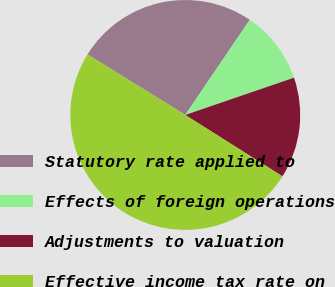Convert chart. <chart><loc_0><loc_0><loc_500><loc_500><pie_chart><fcel>Statutory rate applied to<fcel>Effects of foreign operations<fcel>Adjustments to valuation<fcel>Effective income tax rate on<nl><fcel>25.66%<fcel>10.26%<fcel>14.22%<fcel>49.85%<nl></chart> 